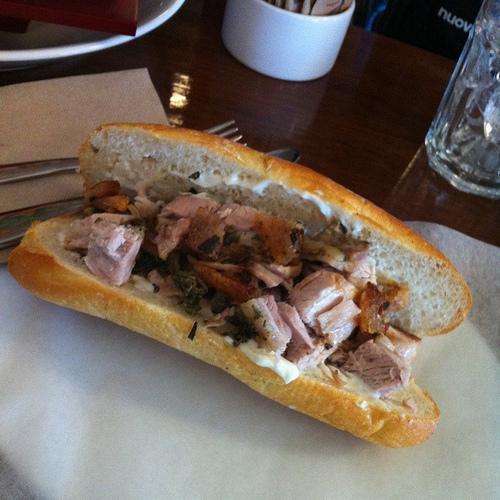How many beverages are there?
Give a very brief answer. 1. 